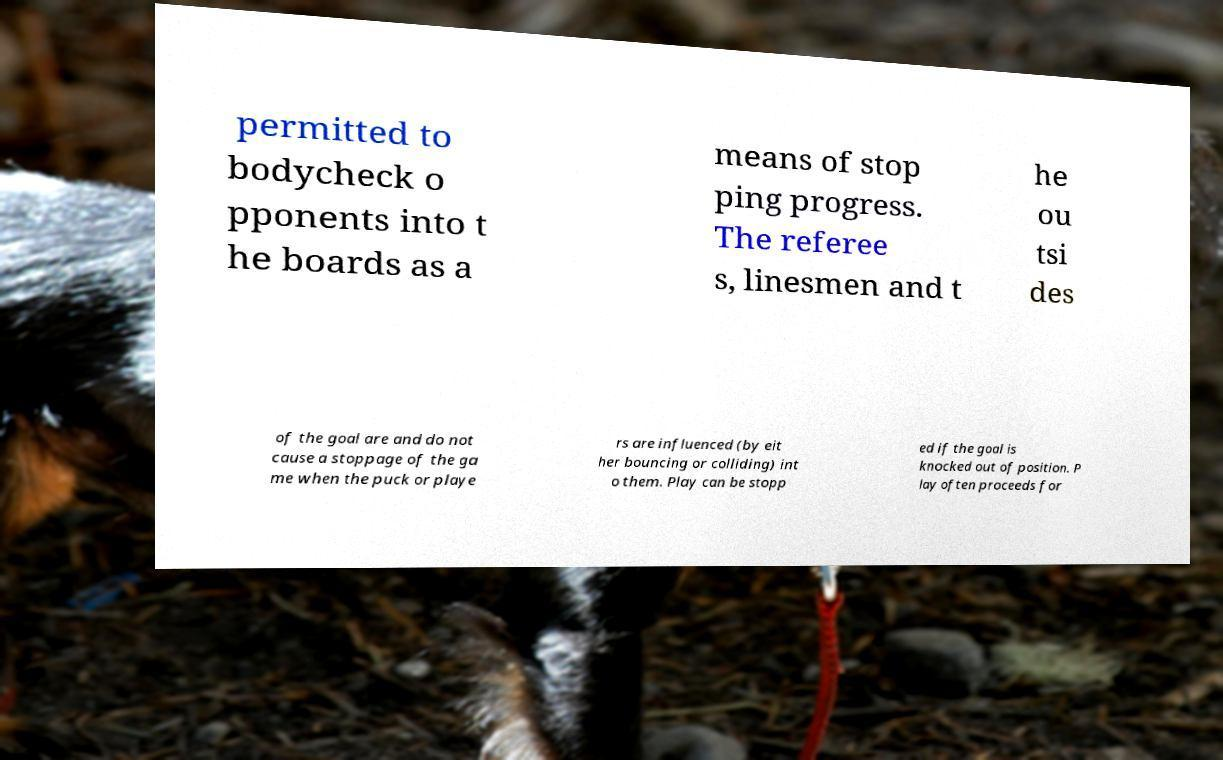Please read and relay the text visible in this image. What does it say? permitted to bodycheck o pponents into t he boards as a means of stop ping progress. The referee s, linesmen and t he ou tsi des of the goal are and do not cause a stoppage of the ga me when the puck or playe rs are influenced (by eit her bouncing or colliding) int o them. Play can be stopp ed if the goal is knocked out of position. P lay often proceeds for 